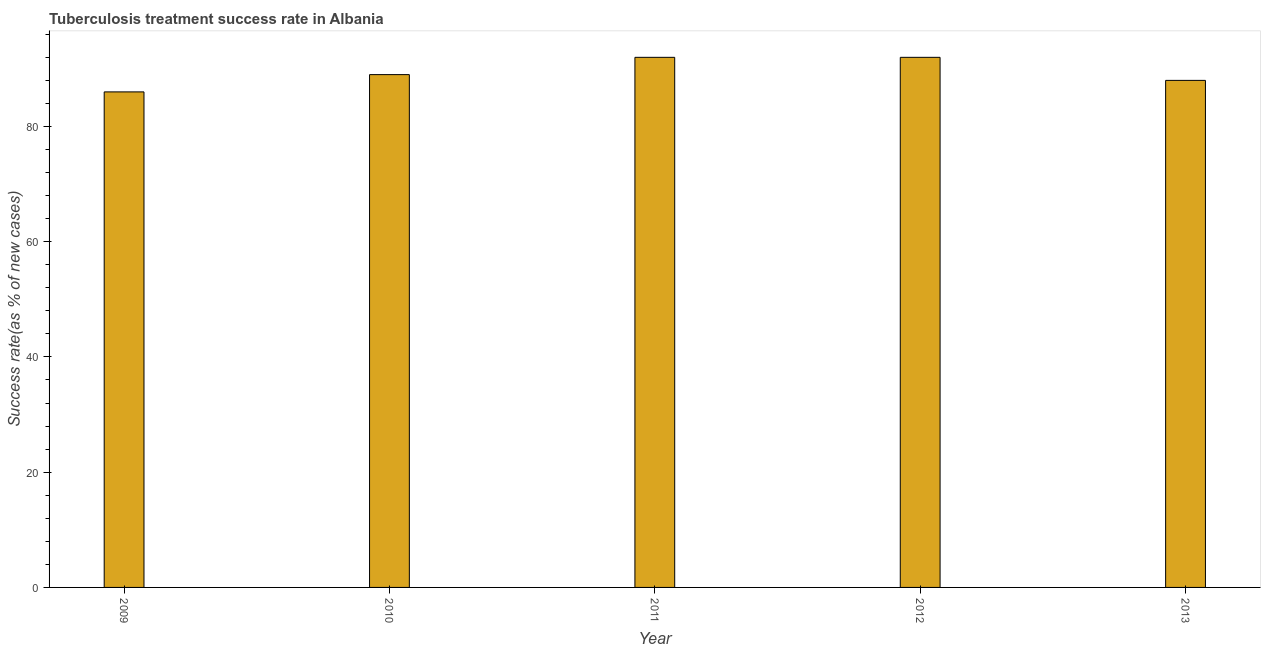Does the graph contain grids?
Make the answer very short. No. What is the title of the graph?
Offer a terse response. Tuberculosis treatment success rate in Albania. What is the label or title of the X-axis?
Make the answer very short. Year. What is the label or title of the Y-axis?
Offer a terse response. Success rate(as % of new cases). What is the tuberculosis treatment success rate in 2012?
Give a very brief answer. 92. Across all years, what is the maximum tuberculosis treatment success rate?
Your response must be concise. 92. Across all years, what is the minimum tuberculosis treatment success rate?
Your answer should be very brief. 86. In which year was the tuberculosis treatment success rate minimum?
Your response must be concise. 2009. What is the sum of the tuberculosis treatment success rate?
Provide a succinct answer. 447. What is the difference between the tuberculosis treatment success rate in 2009 and 2010?
Provide a short and direct response. -3. What is the average tuberculosis treatment success rate per year?
Give a very brief answer. 89. What is the median tuberculosis treatment success rate?
Keep it short and to the point. 89. In how many years, is the tuberculosis treatment success rate greater than 32 %?
Your answer should be very brief. 5. Do a majority of the years between 2009 and 2010 (inclusive) have tuberculosis treatment success rate greater than 84 %?
Your answer should be compact. Yes. Is the sum of the tuberculosis treatment success rate in 2009 and 2011 greater than the maximum tuberculosis treatment success rate across all years?
Your answer should be compact. Yes. What is the difference between the highest and the lowest tuberculosis treatment success rate?
Offer a terse response. 6. In how many years, is the tuberculosis treatment success rate greater than the average tuberculosis treatment success rate taken over all years?
Your answer should be very brief. 2. How many bars are there?
Make the answer very short. 5. Are all the bars in the graph horizontal?
Offer a terse response. No. What is the difference between two consecutive major ticks on the Y-axis?
Your answer should be very brief. 20. What is the Success rate(as % of new cases) of 2009?
Ensure brevity in your answer.  86. What is the Success rate(as % of new cases) of 2010?
Your answer should be very brief. 89. What is the Success rate(as % of new cases) of 2011?
Your response must be concise. 92. What is the Success rate(as % of new cases) of 2012?
Make the answer very short. 92. What is the Success rate(as % of new cases) in 2013?
Offer a very short reply. 88. What is the difference between the Success rate(as % of new cases) in 2009 and 2010?
Your response must be concise. -3. What is the difference between the Success rate(as % of new cases) in 2009 and 2013?
Provide a succinct answer. -2. What is the difference between the Success rate(as % of new cases) in 2011 and 2012?
Your answer should be compact. 0. What is the difference between the Success rate(as % of new cases) in 2011 and 2013?
Your answer should be compact. 4. What is the difference between the Success rate(as % of new cases) in 2012 and 2013?
Your answer should be compact. 4. What is the ratio of the Success rate(as % of new cases) in 2009 to that in 2010?
Give a very brief answer. 0.97. What is the ratio of the Success rate(as % of new cases) in 2009 to that in 2011?
Your response must be concise. 0.94. What is the ratio of the Success rate(as % of new cases) in 2009 to that in 2012?
Keep it short and to the point. 0.94. What is the ratio of the Success rate(as % of new cases) in 2010 to that in 2011?
Offer a very short reply. 0.97. What is the ratio of the Success rate(as % of new cases) in 2010 to that in 2013?
Ensure brevity in your answer.  1.01. What is the ratio of the Success rate(as % of new cases) in 2011 to that in 2013?
Your answer should be compact. 1.04. What is the ratio of the Success rate(as % of new cases) in 2012 to that in 2013?
Offer a terse response. 1.04. 